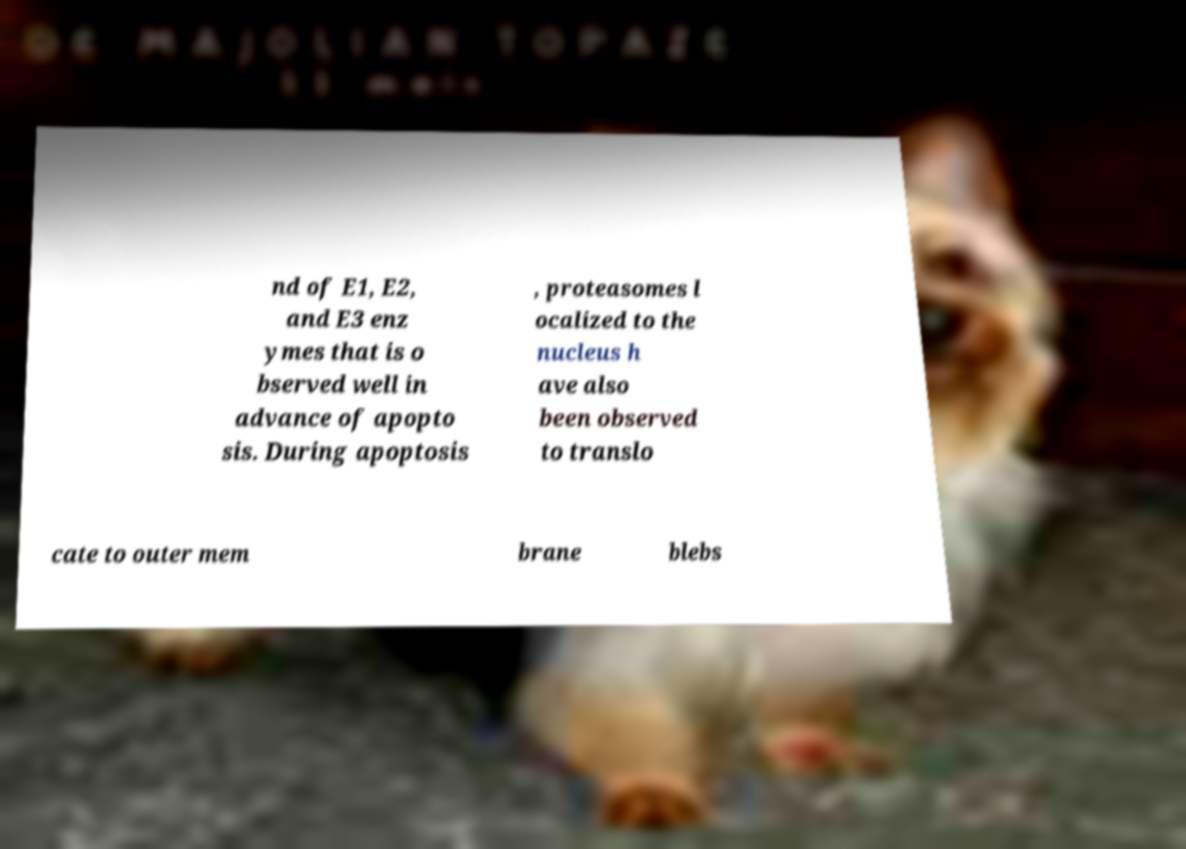Can you accurately transcribe the text from the provided image for me? nd of E1, E2, and E3 enz ymes that is o bserved well in advance of apopto sis. During apoptosis , proteasomes l ocalized to the nucleus h ave also been observed to translo cate to outer mem brane blebs 